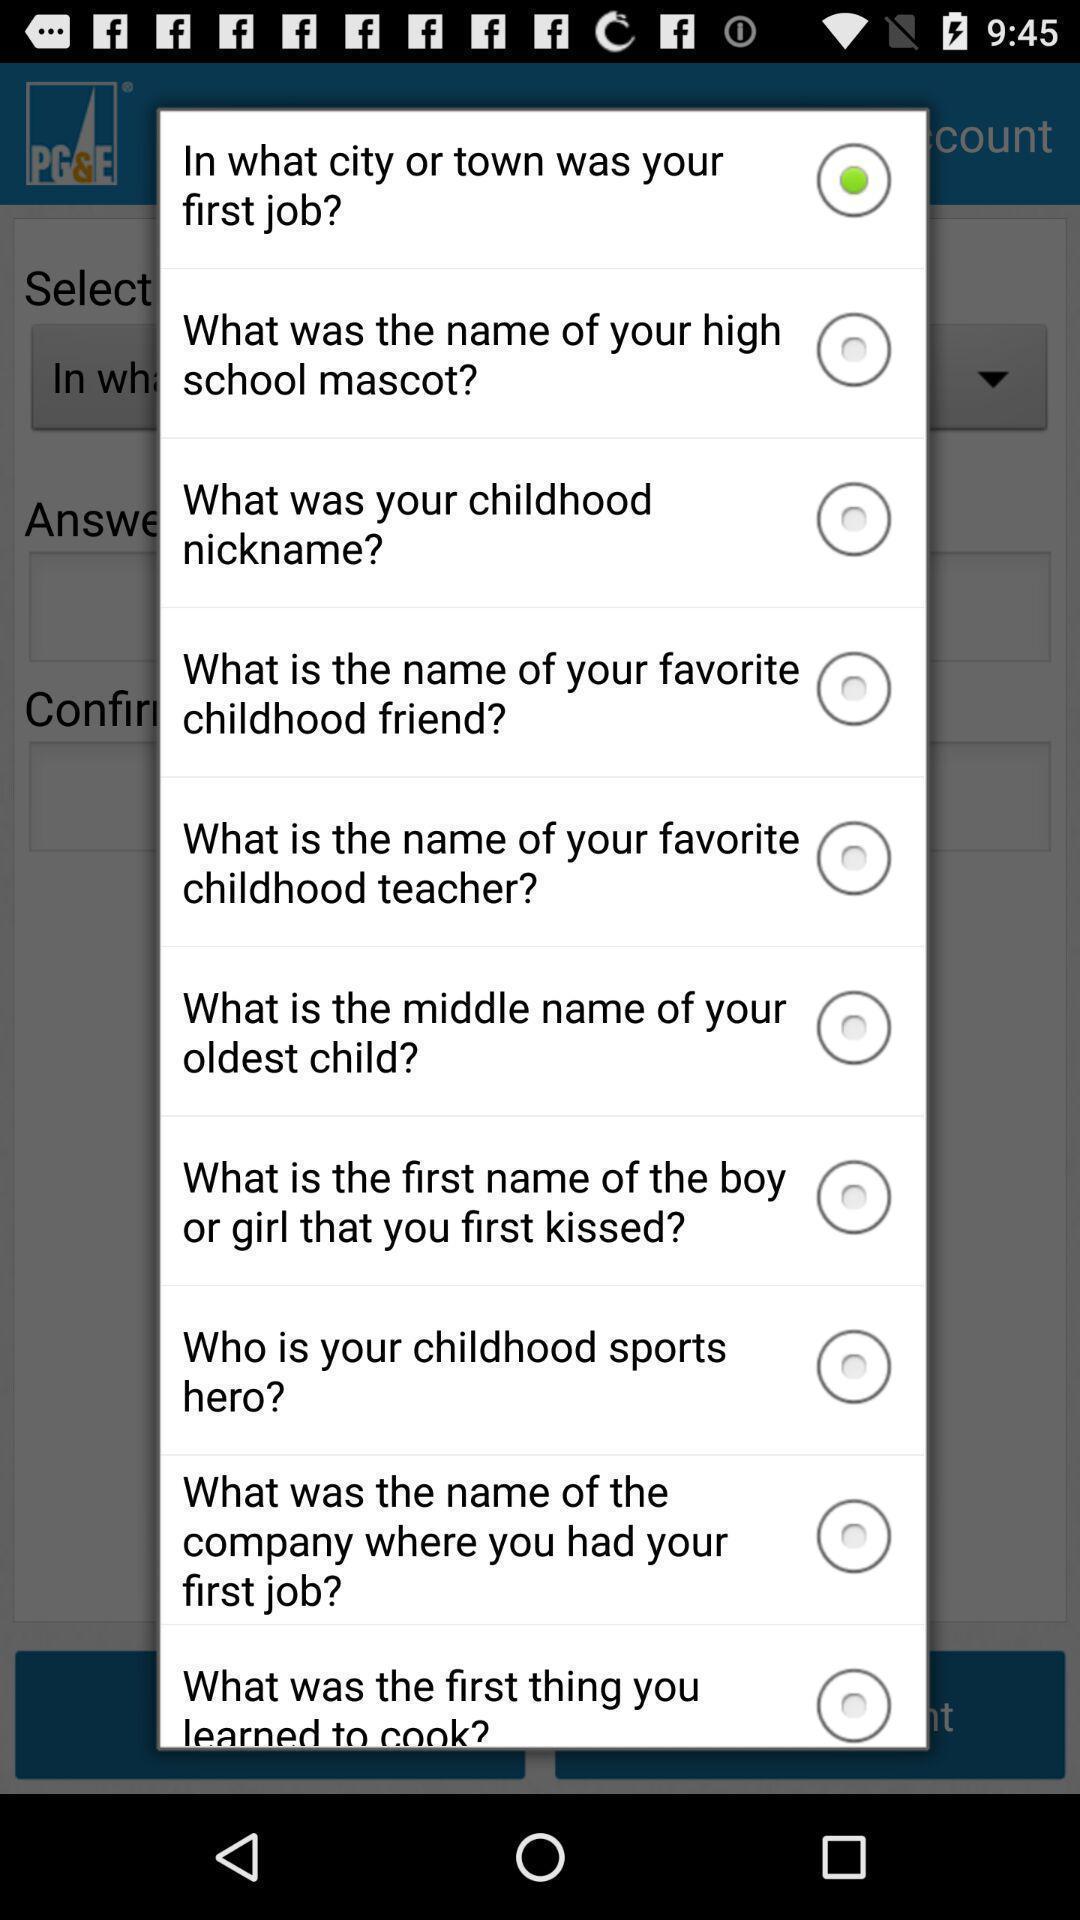Provide a detailed account of this screenshot. Popup showing information about application. 